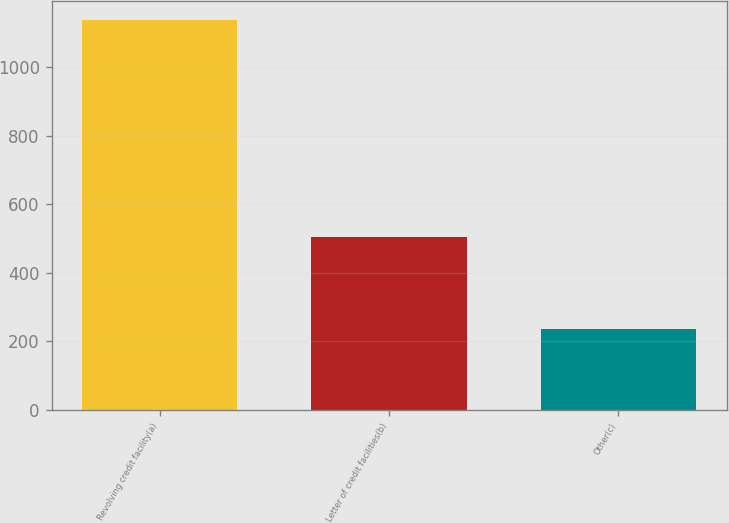<chart> <loc_0><loc_0><loc_500><loc_500><bar_chart><fcel>Revolving credit facility(a)<fcel>Letter of credit facilities(b)<fcel>Other(c)<nl><fcel>1138<fcel>505<fcel>237<nl></chart> 